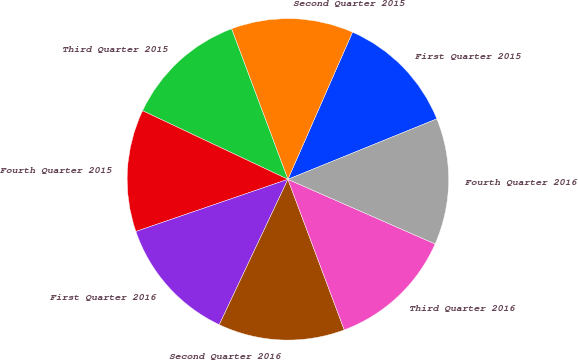<chart> <loc_0><loc_0><loc_500><loc_500><pie_chart><fcel>First Quarter 2015<fcel>Second Quarter 2015<fcel>Third Quarter 2015<fcel>Fourth Quarter 2015<fcel>First Quarter 2016<fcel>Second Quarter 2016<fcel>Third Quarter 2016<fcel>Fourth Quarter 2016<nl><fcel>12.28%<fcel>12.28%<fcel>12.28%<fcel>12.28%<fcel>12.72%<fcel>12.72%<fcel>12.72%<fcel>12.72%<nl></chart> 